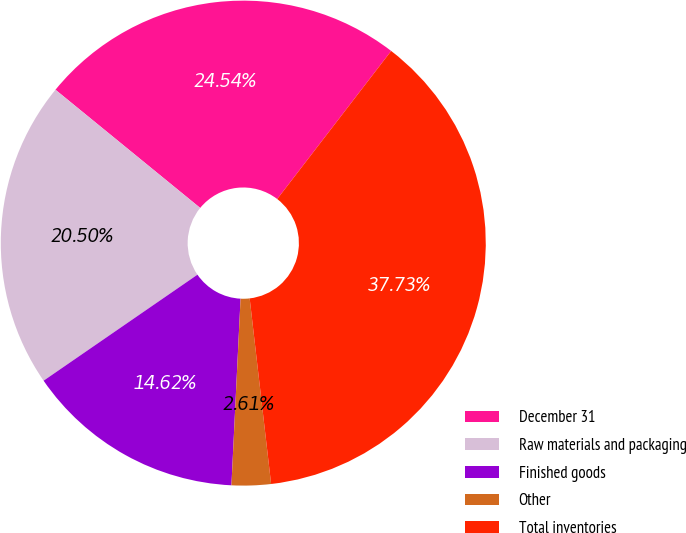<chart> <loc_0><loc_0><loc_500><loc_500><pie_chart><fcel>December 31<fcel>Raw materials and packaging<fcel>Finished goods<fcel>Other<fcel>Total inventories<nl><fcel>24.54%<fcel>20.5%<fcel>14.62%<fcel>2.61%<fcel>37.73%<nl></chart> 